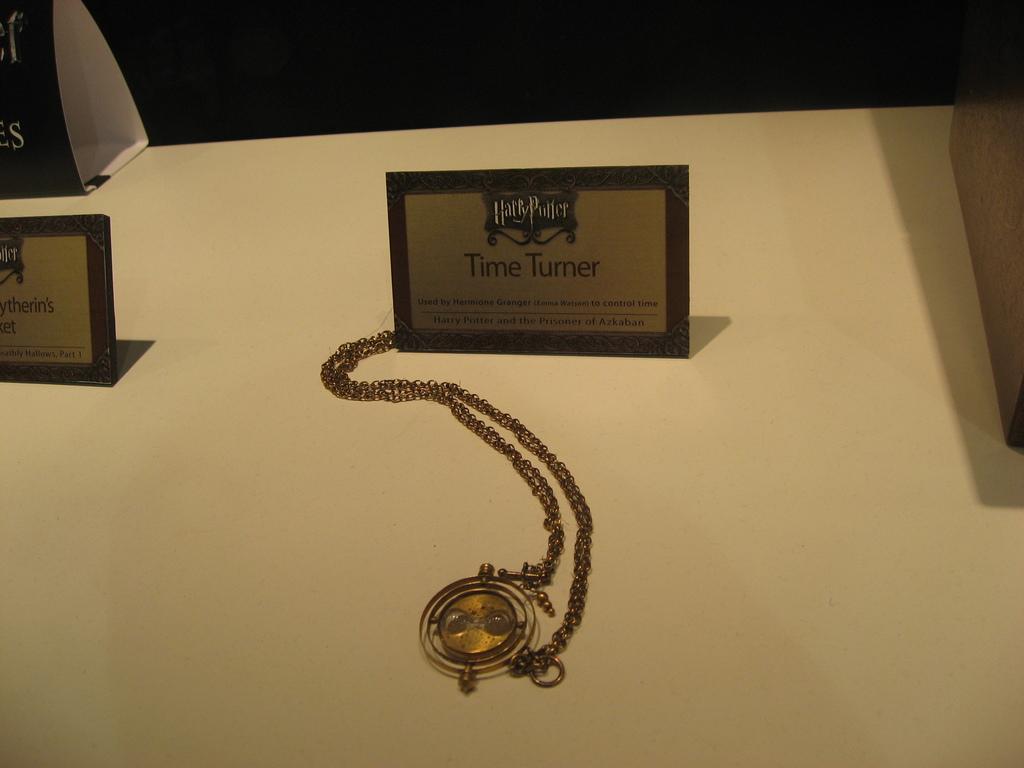Who used the time turner?
Provide a succinct answer. Hermione granger. What book series is mentioned on the plaque?
Give a very brief answer. Harry potter. 